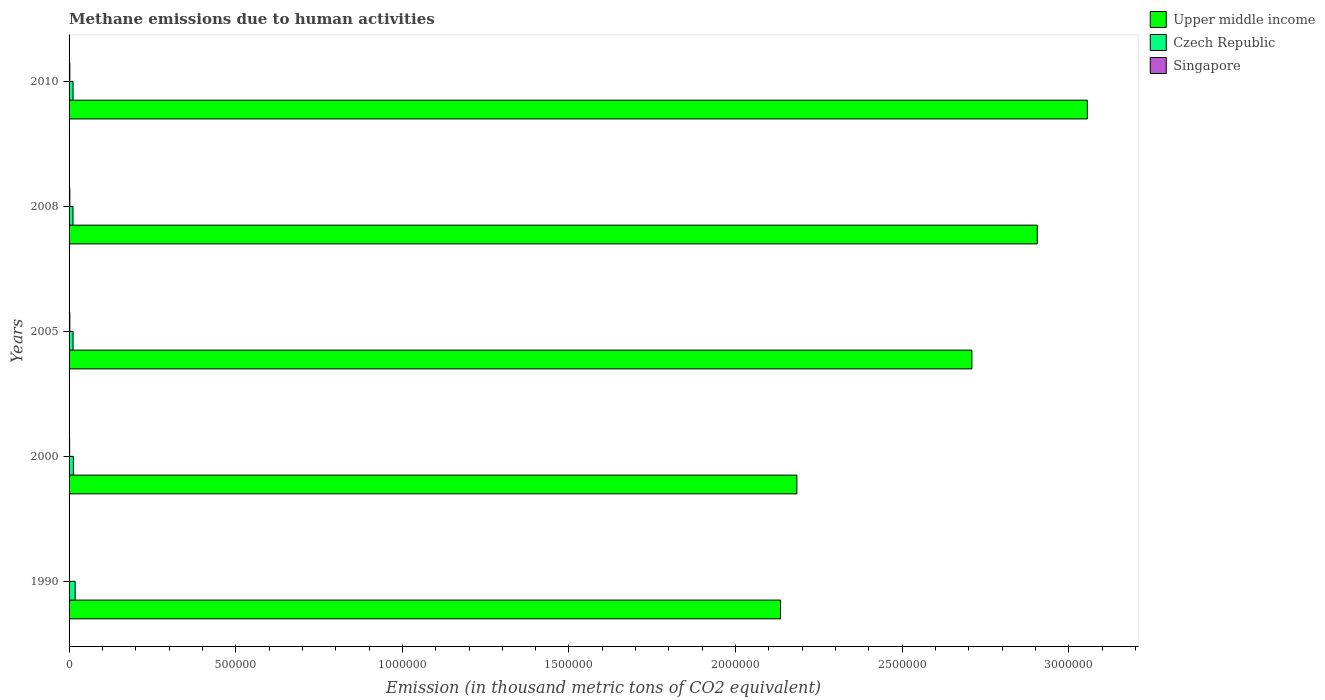How many groups of bars are there?
Provide a short and direct response. 5. Are the number of bars per tick equal to the number of legend labels?
Keep it short and to the point. Yes. How many bars are there on the 5th tick from the bottom?
Give a very brief answer. 3. What is the label of the 2nd group of bars from the top?
Give a very brief answer. 2008. In how many cases, is the number of bars for a given year not equal to the number of legend labels?
Offer a terse response. 0. What is the amount of methane emitted in Upper middle income in 2008?
Your answer should be very brief. 2.91e+06. Across all years, what is the maximum amount of methane emitted in Upper middle income?
Your answer should be very brief. 3.06e+06. Across all years, what is the minimum amount of methane emitted in Czech Republic?
Offer a terse response. 1.19e+04. What is the total amount of methane emitted in Singapore in the graph?
Provide a succinct answer. 9632.9. What is the difference between the amount of methane emitted in Czech Republic in 2000 and that in 2005?
Make the answer very short. 905.4. What is the difference between the amount of methane emitted in Singapore in 2000 and the amount of methane emitted in Upper middle income in 2008?
Provide a short and direct response. -2.90e+06. What is the average amount of methane emitted in Upper middle income per year?
Your answer should be compact. 2.60e+06. In the year 2010, what is the difference between the amount of methane emitted in Upper middle income and amount of methane emitted in Singapore?
Your response must be concise. 3.05e+06. In how many years, is the amount of methane emitted in Czech Republic greater than 1800000 thousand metric tons?
Ensure brevity in your answer.  0. What is the ratio of the amount of methane emitted in Singapore in 1990 to that in 2000?
Give a very brief answer. 0.58. Is the amount of methane emitted in Singapore in 1990 less than that in 2005?
Your answer should be compact. Yes. What is the difference between the highest and the second highest amount of methane emitted in Singapore?
Your response must be concise. 0.6. What is the difference between the highest and the lowest amount of methane emitted in Czech Republic?
Your answer should be very brief. 6388.9. What does the 2nd bar from the top in 1990 represents?
Offer a very short reply. Czech Republic. What does the 3rd bar from the bottom in 2008 represents?
Keep it short and to the point. Singapore. Are all the bars in the graph horizontal?
Your answer should be very brief. Yes. What is the difference between two consecutive major ticks on the X-axis?
Offer a terse response. 5.00e+05. Does the graph contain grids?
Your response must be concise. No. Where does the legend appear in the graph?
Your answer should be very brief. Top right. How many legend labels are there?
Ensure brevity in your answer.  3. How are the legend labels stacked?
Your response must be concise. Vertical. What is the title of the graph?
Offer a very short reply. Methane emissions due to human activities. Does "Samoa" appear as one of the legend labels in the graph?
Make the answer very short. No. What is the label or title of the X-axis?
Offer a very short reply. Emission (in thousand metric tons of CO2 equivalent). What is the label or title of the Y-axis?
Give a very brief answer. Years. What is the Emission (in thousand metric tons of CO2 equivalent) of Upper middle income in 1990?
Give a very brief answer. 2.13e+06. What is the Emission (in thousand metric tons of CO2 equivalent) of Czech Republic in 1990?
Give a very brief answer. 1.82e+04. What is the Emission (in thousand metric tons of CO2 equivalent) in Singapore in 1990?
Your answer should be very brief. 986.7. What is the Emission (in thousand metric tons of CO2 equivalent) in Upper middle income in 2000?
Offer a terse response. 2.18e+06. What is the Emission (in thousand metric tons of CO2 equivalent) of Czech Republic in 2000?
Provide a succinct answer. 1.29e+04. What is the Emission (in thousand metric tons of CO2 equivalent) of Singapore in 2000?
Keep it short and to the point. 1690.6. What is the Emission (in thousand metric tons of CO2 equivalent) of Upper middle income in 2005?
Keep it short and to the point. 2.71e+06. What is the Emission (in thousand metric tons of CO2 equivalent) of Czech Republic in 2005?
Make the answer very short. 1.20e+04. What is the Emission (in thousand metric tons of CO2 equivalent) in Singapore in 2005?
Offer a very short reply. 2276.8. What is the Emission (in thousand metric tons of CO2 equivalent) in Upper middle income in 2008?
Your answer should be very brief. 2.91e+06. What is the Emission (in thousand metric tons of CO2 equivalent) of Czech Republic in 2008?
Offer a very short reply. 1.19e+04. What is the Emission (in thousand metric tons of CO2 equivalent) in Singapore in 2008?
Your answer should be compact. 2339.7. What is the Emission (in thousand metric tons of CO2 equivalent) in Upper middle income in 2010?
Ensure brevity in your answer.  3.06e+06. What is the Emission (in thousand metric tons of CO2 equivalent) in Czech Republic in 2010?
Your answer should be compact. 1.20e+04. What is the Emission (in thousand metric tons of CO2 equivalent) of Singapore in 2010?
Your response must be concise. 2339.1. Across all years, what is the maximum Emission (in thousand metric tons of CO2 equivalent) in Upper middle income?
Offer a very short reply. 3.06e+06. Across all years, what is the maximum Emission (in thousand metric tons of CO2 equivalent) in Czech Republic?
Offer a terse response. 1.82e+04. Across all years, what is the maximum Emission (in thousand metric tons of CO2 equivalent) of Singapore?
Give a very brief answer. 2339.7. Across all years, what is the minimum Emission (in thousand metric tons of CO2 equivalent) of Upper middle income?
Provide a succinct answer. 2.13e+06. Across all years, what is the minimum Emission (in thousand metric tons of CO2 equivalent) of Czech Republic?
Your answer should be very brief. 1.19e+04. Across all years, what is the minimum Emission (in thousand metric tons of CO2 equivalent) of Singapore?
Your response must be concise. 986.7. What is the total Emission (in thousand metric tons of CO2 equivalent) in Upper middle income in the graph?
Give a very brief answer. 1.30e+07. What is the total Emission (in thousand metric tons of CO2 equivalent) in Czech Republic in the graph?
Make the answer very short. 6.71e+04. What is the total Emission (in thousand metric tons of CO2 equivalent) in Singapore in the graph?
Keep it short and to the point. 9632.9. What is the difference between the Emission (in thousand metric tons of CO2 equivalent) in Upper middle income in 1990 and that in 2000?
Keep it short and to the point. -4.89e+04. What is the difference between the Emission (in thousand metric tons of CO2 equivalent) of Czech Republic in 1990 and that in 2000?
Ensure brevity in your answer.  5293.1. What is the difference between the Emission (in thousand metric tons of CO2 equivalent) of Singapore in 1990 and that in 2000?
Make the answer very short. -703.9. What is the difference between the Emission (in thousand metric tons of CO2 equivalent) in Upper middle income in 1990 and that in 2005?
Offer a terse response. -5.74e+05. What is the difference between the Emission (in thousand metric tons of CO2 equivalent) in Czech Republic in 1990 and that in 2005?
Give a very brief answer. 6198.5. What is the difference between the Emission (in thousand metric tons of CO2 equivalent) in Singapore in 1990 and that in 2005?
Your answer should be compact. -1290.1. What is the difference between the Emission (in thousand metric tons of CO2 equivalent) in Upper middle income in 1990 and that in 2008?
Ensure brevity in your answer.  -7.70e+05. What is the difference between the Emission (in thousand metric tons of CO2 equivalent) of Czech Republic in 1990 and that in 2008?
Your answer should be very brief. 6388.9. What is the difference between the Emission (in thousand metric tons of CO2 equivalent) in Singapore in 1990 and that in 2008?
Keep it short and to the point. -1353. What is the difference between the Emission (in thousand metric tons of CO2 equivalent) of Upper middle income in 1990 and that in 2010?
Offer a terse response. -9.20e+05. What is the difference between the Emission (in thousand metric tons of CO2 equivalent) in Czech Republic in 1990 and that in 2010?
Make the answer very short. 6205.9. What is the difference between the Emission (in thousand metric tons of CO2 equivalent) in Singapore in 1990 and that in 2010?
Provide a short and direct response. -1352.4. What is the difference between the Emission (in thousand metric tons of CO2 equivalent) of Upper middle income in 2000 and that in 2005?
Offer a terse response. -5.25e+05. What is the difference between the Emission (in thousand metric tons of CO2 equivalent) in Czech Republic in 2000 and that in 2005?
Keep it short and to the point. 905.4. What is the difference between the Emission (in thousand metric tons of CO2 equivalent) of Singapore in 2000 and that in 2005?
Your answer should be compact. -586.2. What is the difference between the Emission (in thousand metric tons of CO2 equivalent) in Upper middle income in 2000 and that in 2008?
Make the answer very short. -7.21e+05. What is the difference between the Emission (in thousand metric tons of CO2 equivalent) in Czech Republic in 2000 and that in 2008?
Your answer should be very brief. 1095.8. What is the difference between the Emission (in thousand metric tons of CO2 equivalent) of Singapore in 2000 and that in 2008?
Provide a succinct answer. -649.1. What is the difference between the Emission (in thousand metric tons of CO2 equivalent) in Upper middle income in 2000 and that in 2010?
Your answer should be very brief. -8.72e+05. What is the difference between the Emission (in thousand metric tons of CO2 equivalent) of Czech Republic in 2000 and that in 2010?
Give a very brief answer. 912.8. What is the difference between the Emission (in thousand metric tons of CO2 equivalent) in Singapore in 2000 and that in 2010?
Ensure brevity in your answer.  -648.5. What is the difference between the Emission (in thousand metric tons of CO2 equivalent) of Upper middle income in 2005 and that in 2008?
Keep it short and to the point. -1.96e+05. What is the difference between the Emission (in thousand metric tons of CO2 equivalent) of Czech Republic in 2005 and that in 2008?
Ensure brevity in your answer.  190.4. What is the difference between the Emission (in thousand metric tons of CO2 equivalent) in Singapore in 2005 and that in 2008?
Provide a short and direct response. -62.9. What is the difference between the Emission (in thousand metric tons of CO2 equivalent) in Upper middle income in 2005 and that in 2010?
Give a very brief answer. -3.46e+05. What is the difference between the Emission (in thousand metric tons of CO2 equivalent) in Singapore in 2005 and that in 2010?
Provide a short and direct response. -62.3. What is the difference between the Emission (in thousand metric tons of CO2 equivalent) of Upper middle income in 2008 and that in 2010?
Your response must be concise. -1.50e+05. What is the difference between the Emission (in thousand metric tons of CO2 equivalent) in Czech Republic in 2008 and that in 2010?
Ensure brevity in your answer.  -183. What is the difference between the Emission (in thousand metric tons of CO2 equivalent) of Upper middle income in 1990 and the Emission (in thousand metric tons of CO2 equivalent) of Czech Republic in 2000?
Your response must be concise. 2.12e+06. What is the difference between the Emission (in thousand metric tons of CO2 equivalent) in Upper middle income in 1990 and the Emission (in thousand metric tons of CO2 equivalent) in Singapore in 2000?
Ensure brevity in your answer.  2.13e+06. What is the difference between the Emission (in thousand metric tons of CO2 equivalent) of Czech Republic in 1990 and the Emission (in thousand metric tons of CO2 equivalent) of Singapore in 2000?
Your answer should be very brief. 1.65e+04. What is the difference between the Emission (in thousand metric tons of CO2 equivalent) of Upper middle income in 1990 and the Emission (in thousand metric tons of CO2 equivalent) of Czech Republic in 2005?
Your answer should be compact. 2.12e+06. What is the difference between the Emission (in thousand metric tons of CO2 equivalent) in Upper middle income in 1990 and the Emission (in thousand metric tons of CO2 equivalent) in Singapore in 2005?
Your answer should be compact. 2.13e+06. What is the difference between the Emission (in thousand metric tons of CO2 equivalent) in Czech Republic in 1990 and the Emission (in thousand metric tons of CO2 equivalent) in Singapore in 2005?
Make the answer very short. 1.60e+04. What is the difference between the Emission (in thousand metric tons of CO2 equivalent) of Upper middle income in 1990 and the Emission (in thousand metric tons of CO2 equivalent) of Czech Republic in 2008?
Ensure brevity in your answer.  2.12e+06. What is the difference between the Emission (in thousand metric tons of CO2 equivalent) of Upper middle income in 1990 and the Emission (in thousand metric tons of CO2 equivalent) of Singapore in 2008?
Provide a succinct answer. 2.13e+06. What is the difference between the Emission (in thousand metric tons of CO2 equivalent) of Czech Republic in 1990 and the Emission (in thousand metric tons of CO2 equivalent) of Singapore in 2008?
Your answer should be compact. 1.59e+04. What is the difference between the Emission (in thousand metric tons of CO2 equivalent) of Upper middle income in 1990 and the Emission (in thousand metric tons of CO2 equivalent) of Czech Republic in 2010?
Your response must be concise. 2.12e+06. What is the difference between the Emission (in thousand metric tons of CO2 equivalent) of Upper middle income in 1990 and the Emission (in thousand metric tons of CO2 equivalent) of Singapore in 2010?
Make the answer very short. 2.13e+06. What is the difference between the Emission (in thousand metric tons of CO2 equivalent) in Czech Republic in 1990 and the Emission (in thousand metric tons of CO2 equivalent) in Singapore in 2010?
Your answer should be compact. 1.59e+04. What is the difference between the Emission (in thousand metric tons of CO2 equivalent) in Upper middle income in 2000 and the Emission (in thousand metric tons of CO2 equivalent) in Czech Republic in 2005?
Keep it short and to the point. 2.17e+06. What is the difference between the Emission (in thousand metric tons of CO2 equivalent) of Upper middle income in 2000 and the Emission (in thousand metric tons of CO2 equivalent) of Singapore in 2005?
Ensure brevity in your answer.  2.18e+06. What is the difference between the Emission (in thousand metric tons of CO2 equivalent) in Czech Republic in 2000 and the Emission (in thousand metric tons of CO2 equivalent) in Singapore in 2005?
Your response must be concise. 1.07e+04. What is the difference between the Emission (in thousand metric tons of CO2 equivalent) in Upper middle income in 2000 and the Emission (in thousand metric tons of CO2 equivalent) in Czech Republic in 2008?
Provide a succinct answer. 2.17e+06. What is the difference between the Emission (in thousand metric tons of CO2 equivalent) in Upper middle income in 2000 and the Emission (in thousand metric tons of CO2 equivalent) in Singapore in 2008?
Your response must be concise. 2.18e+06. What is the difference between the Emission (in thousand metric tons of CO2 equivalent) of Czech Republic in 2000 and the Emission (in thousand metric tons of CO2 equivalent) of Singapore in 2008?
Offer a terse response. 1.06e+04. What is the difference between the Emission (in thousand metric tons of CO2 equivalent) of Upper middle income in 2000 and the Emission (in thousand metric tons of CO2 equivalent) of Czech Republic in 2010?
Your answer should be very brief. 2.17e+06. What is the difference between the Emission (in thousand metric tons of CO2 equivalent) in Upper middle income in 2000 and the Emission (in thousand metric tons of CO2 equivalent) in Singapore in 2010?
Make the answer very short. 2.18e+06. What is the difference between the Emission (in thousand metric tons of CO2 equivalent) in Czech Republic in 2000 and the Emission (in thousand metric tons of CO2 equivalent) in Singapore in 2010?
Offer a terse response. 1.06e+04. What is the difference between the Emission (in thousand metric tons of CO2 equivalent) of Upper middle income in 2005 and the Emission (in thousand metric tons of CO2 equivalent) of Czech Republic in 2008?
Provide a succinct answer. 2.70e+06. What is the difference between the Emission (in thousand metric tons of CO2 equivalent) of Upper middle income in 2005 and the Emission (in thousand metric tons of CO2 equivalent) of Singapore in 2008?
Give a very brief answer. 2.71e+06. What is the difference between the Emission (in thousand metric tons of CO2 equivalent) in Czech Republic in 2005 and the Emission (in thousand metric tons of CO2 equivalent) in Singapore in 2008?
Offer a terse response. 9701.1. What is the difference between the Emission (in thousand metric tons of CO2 equivalent) of Upper middle income in 2005 and the Emission (in thousand metric tons of CO2 equivalent) of Czech Republic in 2010?
Your answer should be very brief. 2.70e+06. What is the difference between the Emission (in thousand metric tons of CO2 equivalent) of Upper middle income in 2005 and the Emission (in thousand metric tons of CO2 equivalent) of Singapore in 2010?
Offer a very short reply. 2.71e+06. What is the difference between the Emission (in thousand metric tons of CO2 equivalent) of Czech Republic in 2005 and the Emission (in thousand metric tons of CO2 equivalent) of Singapore in 2010?
Your answer should be very brief. 9701.7. What is the difference between the Emission (in thousand metric tons of CO2 equivalent) in Upper middle income in 2008 and the Emission (in thousand metric tons of CO2 equivalent) in Czech Republic in 2010?
Ensure brevity in your answer.  2.89e+06. What is the difference between the Emission (in thousand metric tons of CO2 equivalent) in Upper middle income in 2008 and the Emission (in thousand metric tons of CO2 equivalent) in Singapore in 2010?
Offer a very short reply. 2.90e+06. What is the difference between the Emission (in thousand metric tons of CO2 equivalent) in Czech Republic in 2008 and the Emission (in thousand metric tons of CO2 equivalent) in Singapore in 2010?
Your response must be concise. 9511.3. What is the average Emission (in thousand metric tons of CO2 equivalent) of Upper middle income per year?
Offer a terse response. 2.60e+06. What is the average Emission (in thousand metric tons of CO2 equivalent) of Czech Republic per year?
Offer a very short reply. 1.34e+04. What is the average Emission (in thousand metric tons of CO2 equivalent) of Singapore per year?
Provide a short and direct response. 1926.58. In the year 1990, what is the difference between the Emission (in thousand metric tons of CO2 equivalent) in Upper middle income and Emission (in thousand metric tons of CO2 equivalent) in Czech Republic?
Provide a short and direct response. 2.12e+06. In the year 1990, what is the difference between the Emission (in thousand metric tons of CO2 equivalent) of Upper middle income and Emission (in thousand metric tons of CO2 equivalent) of Singapore?
Ensure brevity in your answer.  2.13e+06. In the year 1990, what is the difference between the Emission (in thousand metric tons of CO2 equivalent) in Czech Republic and Emission (in thousand metric tons of CO2 equivalent) in Singapore?
Keep it short and to the point. 1.73e+04. In the year 2000, what is the difference between the Emission (in thousand metric tons of CO2 equivalent) in Upper middle income and Emission (in thousand metric tons of CO2 equivalent) in Czech Republic?
Give a very brief answer. 2.17e+06. In the year 2000, what is the difference between the Emission (in thousand metric tons of CO2 equivalent) of Upper middle income and Emission (in thousand metric tons of CO2 equivalent) of Singapore?
Provide a succinct answer. 2.18e+06. In the year 2000, what is the difference between the Emission (in thousand metric tons of CO2 equivalent) of Czech Republic and Emission (in thousand metric tons of CO2 equivalent) of Singapore?
Offer a terse response. 1.13e+04. In the year 2005, what is the difference between the Emission (in thousand metric tons of CO2 equivalent) in Upper middle income and Emission (in thousand metric tons of CO2 equivalent) in Czech Republic?
Your answer should be compact. 2.70e+06. In the year 2005, what is the difference between the Emission (in thousand metric tons of CO2 equivalent) in Upper middle income and Emission (in thousand metric tons of CO2 equivalent) in Singapore?
Offer a terse response. 2.71e+06. In the year 2005, what is the difference between the Emission (in thousand metric tons of CO2 equivalent) in Czech Republic and Emission (in thousand metric tons of CO2 equivalent) in Singapore?
Your response must be concise. 9764. In the year 2008, what is the difference between the Emission (in thousand metric tons of CO2 equivalent) of Upper middle income and Emission (in thousand metric tons of CO2 equivalent) of Czech Republic?
Offer a very short reply. 2.89e+06. In the year 2008, what is the difference between the Emission (in thousand metric tons of CO2 equivalent) of Upper middle income and Emission (in thousand metric tons of CO2 equivalent) of Singapore?
Ensure brevity in your answer.  2.90e+06. In the year 2008, what is the difference between the Emission (in thousand metric tons of CO2 equivalent) in Czech Republic and Emission (in thousand metric tons of CO2 equivalent) in Singapore?
Make the answer very short. 9510.7. In the year 2010, what is the difference between the Emission (in thousand metric tons of CO2 equivalent) of Upper middle income and Emission (in thousand metric tons of CO2 equivalent) of Czech Republic?
Provide a succinct answer. 3.04e+06. In the year 2010, what is the difference between the Emission (in thousand metric tons of CO2 equivalent) in Upper middle income and Emission (in thousand metric tons of CO2 equivalent) in Singapore?
Offer a very short reply. 3.05e+06. In the year 2010, what is the difference between the Emission (in thousand metric tons of CO2 equivalent) in Czech Republic and Emission (in thousand metric tons of CO2 equivalent) in Singapore?
Keep it short and to the point. 9694.3. What is the ratio of the Emission (in thousand metric tons of CO2 equivalent) in Upper middle income in 1990 to that in 2000?
Give a very brief answer. 0.98. What is the ratio of the Emission (in thousand metric tons of CO2 equivalent) in Czech Republic in 1990 to that in 2000?
Ensure brevity in your answer.  1.41. What is the ratio of the Emission (in thousand metric tons of CO2 equivalent) in Singapore in 1990 to that in 2000?
Provide a short and direct response. 0.58. What is the ratio of the Emission (in thousand metric tons of CO2 equivalent) of Upper middle income in 1990 to that in 2005?
Provide a short and direct response. 0.79. What is the ratio of the Emission (in thousand metric tons of CO2 equivalent) of Czech Republic in 1990 to that in 2005?
Make the answer very short. 1.51. What is the ratio of the Emission (in thousand metric tons of CO2 equivalent) of Singapore in 1990 to that in 2005?
Provide a succinct answer. 0.43. What is the ratio of the Emission (in thousand metric tons of CO2 equivalent) of Upper middle income in 1990 to that in 2008?
Your answer should be compact. 0.73. What is the ratio of the Emission (in thousand metric tons of CO2 equivalent) in Czech Republic in 1990 to that in 2008?
Give a very brief answer. 1.54. What is the ratio of the Emission (in thousand metric tons of CO2 equivalent) in Singapore in 1990 to that in 2008?
Ensure brevity in your answer.  0.42. What is the ratio of the Emission (in thousand metric tons of CO2 equivalent) of Upper middle income in 1990 to that in 2010?
Your answer should be very brief. 0.7. What is the ratio of the Emission (in thousand metric tons of CO2 equivalent) in Czech Republic in 1990 to that in 2010?
Give a very brief answer. 1.52. What is the ratio of the Emission (in thousand metric tons of CO2 equivalent) in Singapore in 1990 to that in 2010?
Offer a terse response. 0.42. What is the ratio of the Emission (in thousand metric tons of CO2 equivalent) in Upper middle income in 2000 to that in 2005?
Provide a succinct answer. 0.81. What is the ratio of the Emission (in thousand metric tons of CO2 equivalent) in Czech Republic in 2000 to that in 2005?
Make the answer very short. 1.08. What is the ratio of the Emission (in thousand metric tons of CO2 equivalent) of Singapore in 2000 to that in 2005?
Make the answer very short. 0.74. What is the ratio of the Emission (in thousand metric tons of CO2 equivalent) of Upper middle income in 2000 to that in 2008?
Offer a very short reply. 0.75. What is the ratio of the Emission (in thousand metric tons of CO2 equivalent) in Czech Republic in 2000 to that in 2008?
Your response must be concise. 1.09. What is the ratio of the Emission (in thousand metric tons of CO2 equivalent) in Singapore in 2000 to that in 2008?
Offer a terse response. 0.72. What is the ratio of the Emission (in thousand metric tons of CO2 equivalent) in Upper middle income in 2000 to that in 2010?
Give a very brief answer. 0.71. What is the ratio of the Emission (in thousand metric tons of CO2 equivalent) in Czech Republic in 2000 to that in 2010?
Your answer should be very brief. 1.08. What is the ratio of the Emission (in thousand metric tons of CO2 equivalent) of Singapore in 2000 to that in 2010?
Make the answer very short. 0.72. What is the ratio of the Emission (in thousand metric tons of CO2 equivalent) in Upper middle income in 2005 to that in 2008?
Offer a very short reply. 0.93. What is the ratio of the Emission (in thousand metric tons of CO2 equivalent) of Czech Republic in 2005 to that in 2008?
Provide a succinct answer. 1.02. What is the ratio of the Emission (in thousand metric tons of CO2 equivalent) in Singapore in 2005 to that in 2008?
Offer a very short reply. 0.97. What is the ratio of the Emission (in thousand metric tons of CO2 equivalent) in Upper middle income in 2005 to that in 2010?
Provide a short and direct response. 0.89. What is the ratio of the Emission (in thousand metric tons of CO2 equivalent) in Singapore in 2005 to that in 2010?
Offer a terse response. 0.97. What is the ratio of the Emission (in thousand metric tons of CO2 equivalent) in Upper middle income in 2008 to that in 2010?
Provide a short and direct response. 0.95. What is the difference between the highest and the second highest Emission (in thousand metric tons of CO2 equivalent) of Upper middle income?
Offer a very short reply. 1.50e+05. What is the difference between the highest and the second highest Emission (in thousand metric tons of CO2 equivalent) of Czech Republic?
Offer a very short reply. 5293.1. What is the difference between the highest and the second highest Emission (in thousand metric tons of CO2 equivalent) in Singapore?
Offer a terse response. 0.6. What is the difference between the highest and the lowest Emission (in thousand metric tons of CO2 equivalent) in Upper middle income?
Your answer should be compact. 9.20e+05. What is the difference between the highest and the lowest Emission (in thousand metric tons of CO2 equivalent) in Czech Republic?
Offer a terse response. 6388.9. What is the difference between the highest and the lowest Emission (in thousand metric tons of CO2 equivalent) of Singapore?
Give a very brief answer. 1353. 